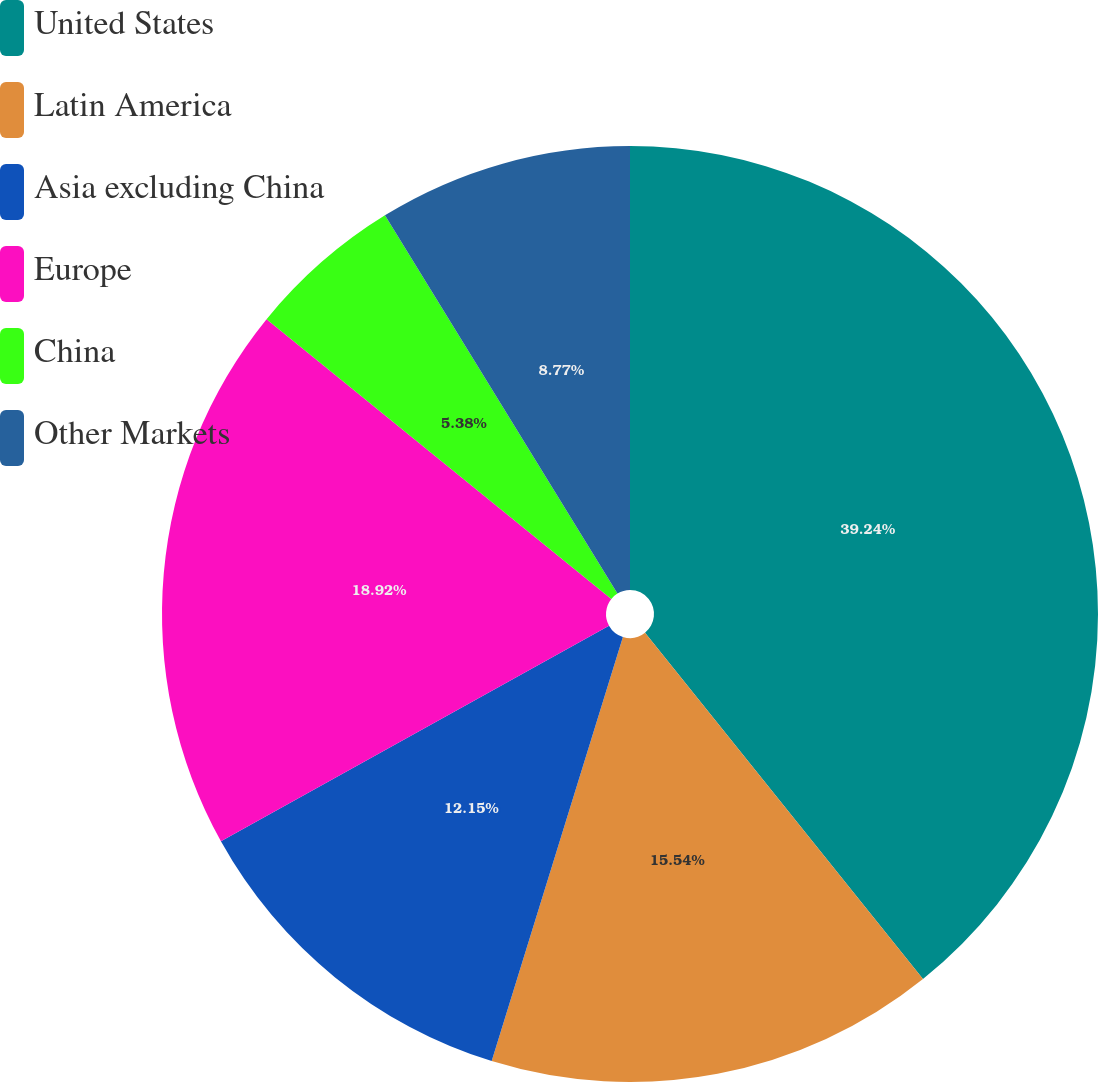Convert chart to OTSL. <chart><loc_0><loc_0><loc_500><loc_500><pie_chart><fcel>United States<fcel>Latin America<fcel>Asia excluding China<fcel>Europe<fcel>China<fcel>Other Markets<nl><fcel>39.23%<fcel>15.54%<fcel>12.15%<fcel>18.92%<fcel>5.38%<fcel>8.77%<nl></chart> 